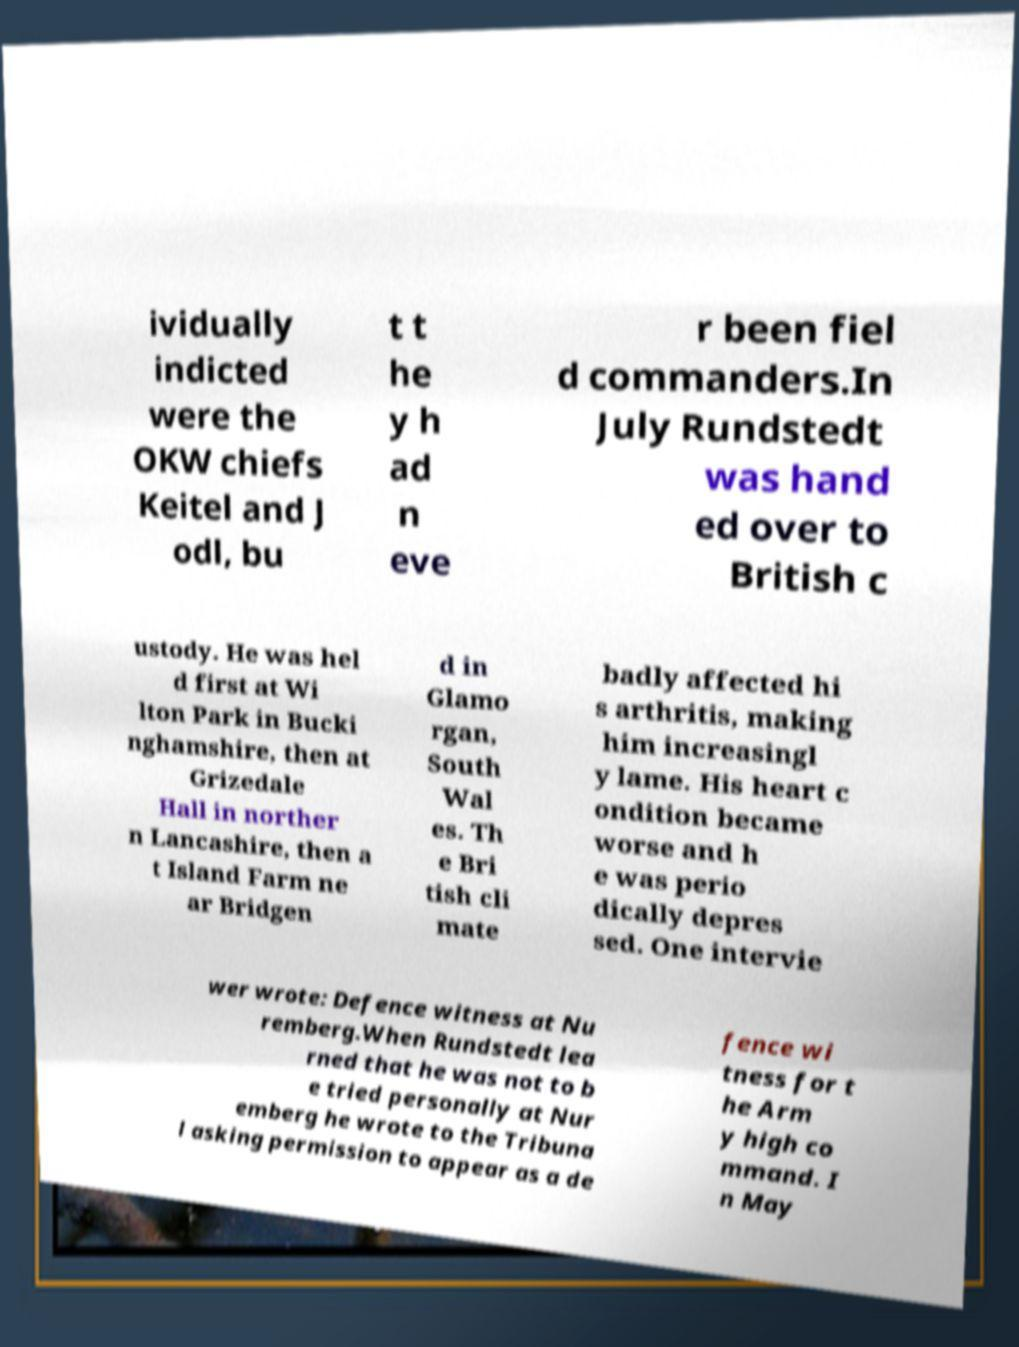I need the written content from this picture converted into text. Can you do that? ividually indicted were the OKW chiefs Keitel and J odl, bu t t he y h ad n eve r been fiel d commanders.In July Rundstedt was hand ed over to British c ustody. He was hel d first at Wi lton Park in Bucki nghamshire, then at Grizedale Hall in norther n Lancashire, then a t Island Farm ne ar Bridgen d in Glamo rgan, South Wal es. Th e Bri tish cli mate badly affected hi s arthritis, making him increasingl y lame. His heart c ondition became worse and h e was perio dically depres sed. One intervie wer wrote: Defence witness at Nu remberg.When Rundstedt lea rned that he was not to b e tried personally at Nur emberg he wrote to the Tribuna l asking permission to appear as a de fence wi tness for t he Arm y high co mmand. I n May 